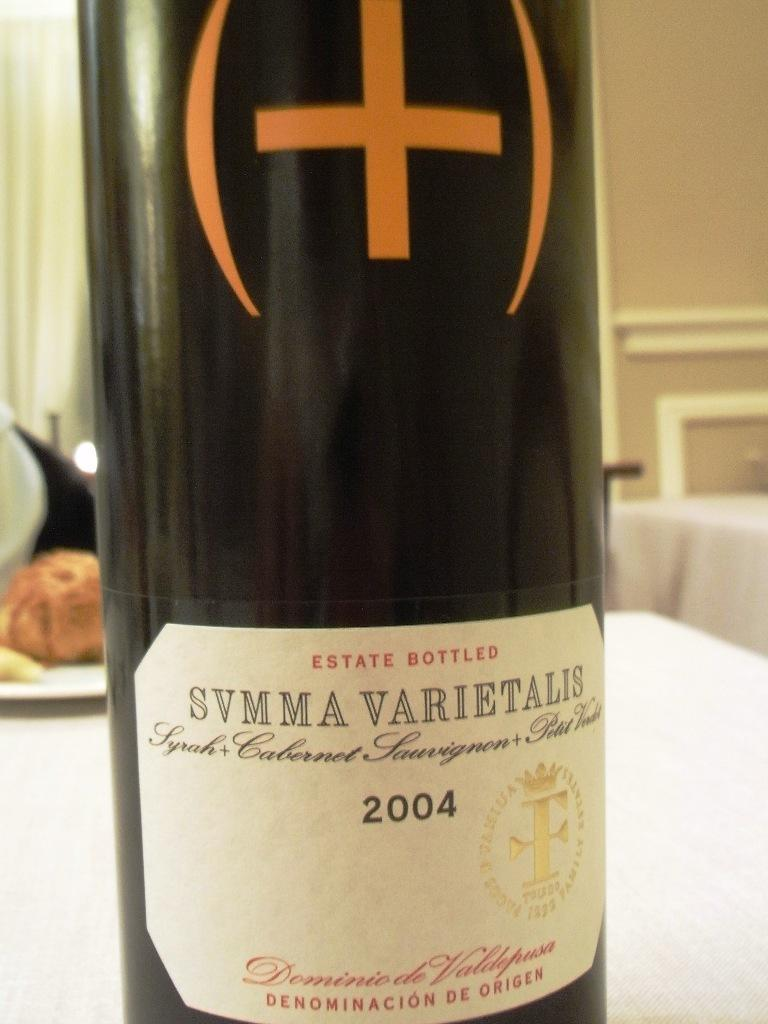Provide a one-sentence caption for the provided image. A bottle of SVMMA VARIETALIS wine from 2004 is displayed on a table. 